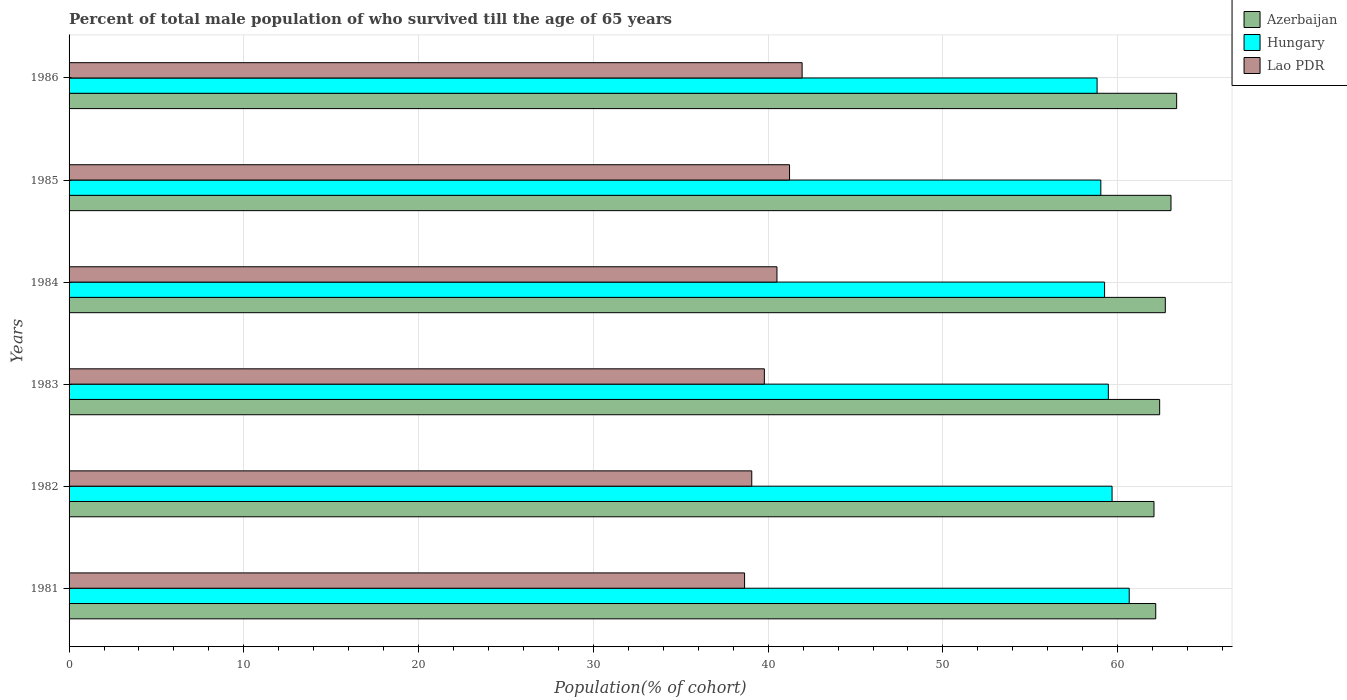How many different coloured bars are there?
Offer a very short reply. 3. How many groups of bars are there?
Make the answer very short. 6. What is the percentage of total male population who survived till the age of 65 years in Azerbaijan in 1984?
Ensure brevity in your answer.  62.73. Across all years, what is the maximum percentage of total male population who survived till the age of 65 years in Hungary?
Keep it short and to the point. 60.66. Across all years, what is the minimum percentage of total male population who survived till the age of 65 years in Hungary?
Give a very brief answer. 58.82. In which year was the percentage of total male population who survived till the age of 65 years in Lao PDR minimum?
Ensure brevity in your answer.  1981. What is the total percentage of total male population who survived till the age of 65 years in Azerbaijan in the graph?
Give a very brief answer. 375.81. What is the difference between the percentage of total male population who survived till the age of 65 years in Hungary in 1981 and that in 1984?
Keep it short and to the point. 1.41. What is the difference between the percentage of total male population who survived till the age of 65 years in Hungary in 1981 and the percentage of total male population who survived till the age of 65 years in Lao PDR in 1985?
Your answer should be compact. 19.44. What is the average percentage of total male population who survived till the age of 65 years in Lao PDR per year?
Provide a succinct answer. 40.19. In the year 1984, what is the difference between the percentage of total male population who survived till the age of 65 years in Azerbaijan and percentage of total male population who survived till the age of 65 years in Hungary?
Give a very brief answer. 3.48. What is the ratio of the percentage of total male population who survived till the age of 65 years in Hungary in 1983 to that in 1986?
Provide a short and direct response. 1.01. Is the difference between the percentage of total male population who survived till the age of 65 years in Azerbaijan in 1981 and 1983 greater than the difference between the percentage of total male population who survived till the age of 65 years in Hungary in 1981 and 1983?
Make the answer very short. No. What is the difference between the highest and the second highest percentage of total male population who survived till the age of 65 years in Lao PDR?
Ensure brevity in your answer.  0.72. What is the difference between the highest and the lowest percentage of total male population who survived till the age of 65 years in Lao PDR?
Offer a very short reply. 3.29. In how many years, is the percentage of total male population who survived till the age of 65 years in Hungary greater than the average percentage of total male population who survived till the age of 65 years in Hungary taken over all years?
Make the answer very short. 2. What does the 2nd bar from the top in 1984 represents?
Your answer should be very brief. Hungary. What does the 1st bar from the bottom in 1985 represents?
Provide a succinct answer. Azerbaijan. Is it the case that in every year, the sum of the percentage of total male population who survived till the age of 65 years in Lao PDR and percentage of total male population who survived till the age of 65 years in Hungary is greater than the percentage of total male population who survived till the age of 65 years in Azerbaijan?
Keep it short and to the point. Yes. Are the values on the major ticks of X-axis written in scientific E-notation?
Offer a very short reply. No. How many legend labels are there?
Ensure brevity in your answer.  3. What is the title of the graph?
Your answer should be very brief. Percent of total male population of who survived till the age of 65 years. Does "Cabo Verde" appear as one of the legend labels in the graph?
Your answer should be very brief. No. What is the label or title of the X-axis?
Make the answer very short. Population(% of cohort). What is the label or title of the Y-axis?
Your answer should be very brief. Years. What is the Population(% of cohort) of Azerbaijan in 1981?
Offer a very short reply. 62.18. What is the Population(% of cohort) in Hungary in 1981?
Make the answer very short. 60.66. What is the Population(% of cohort) of Lao PDR in 1981?
Offer a terse response. 38.65. What is the Population(% of cohort) in Azerbaijan in 1982?
Provide a succinct answer. 62.08. What is the Population(% of cohort) in Hungary in 1982?
Make the answer very short. 59.68. What is the Population(% of cohort) in Lao PDR in 1982?
Ensure brevity in your answer.  39.06. What is the Population(% of cohort) of Azerbaijan in 1983?
Your answer should be very brief. 62.4. What is the Population(% of cohort) of Hungary in 1983?
Your response must be concise. 59.46. What is the Population(% of cohort) in Lao PDR in 1983?
Give a very brief answer. 39.78. What is the Population(% of cohort) of Azerbaijan in 1984?
Your answer should be very brief. 62.73. What is the Population(% of cohort) of Hungary in 1984?
Ensure brevity in your answer.  59.25. What is the Population(% of cohort) of Lao PDR in 1984?
Your answer should be very brief. 40.5. What is the Population(% of cohort) of Azerbaijan in 1985?
Your answer should be very brief. 63.05. What is the Population(% of cohort) in Hungary in 1985?
Keep it short and to the point. 59.04. What is the Population(% of cohort) of Lao PDR in 1985?
Ensure brevity in your answer.  41.22. What is the Population(% of cohort) of Azerbaijan in 1986?
Ensure brevity in your answer.  63.37. What is the Population(% of cohort) in Hungary in 1986?
Your answer should be very brief. 58.82. What is the Population(% of cohort) in Lao PDR in 1986?
Ensure brevity in your answer.  41.94. Across all years, what is the maximum Population(% of cohort) in Azerbaijan?
Your response must be concise. 63.37. Across all years, what is the maximum Population(% of cohort) of Hungary?
Provide a short and direct response. 60.66. Across all years, what is the maximum Population(% of cohort) of Lao PDR?
Your answer should be very brief. 41.94. Across all years, what is the minimum Population(% of cohort) in Azerbaijan?
Offer a terse response. 62.08. Across all years, what is the minimum Population(% of cohort) in Hungary?
Provide a short and direct response. 58.82. Across all years, what is the minimum Population(% of cohort) in Lao PDR?
Your response must be concise. 38.65. What is the total Population(% of cohort) in Azerbaijan in the graph?
Your response must be concise. 375.81. What is the total Population(% of cohort) in Hungary in the graph?
Offer a very short reply. 356.91. What is the total Population(% of cohort) in Lao PDR in the graph?
Give a very brief answer. 241.17. What is the difference between the Population(% of cohort) in Azerbaijan in 1981 and that in 1982?
Ensure brevity in your answer.  0.1. What is the difference between the Population(% of cohort) in Hungary in 1981 and that in 1982?
Make the answer very short. 0.98. What is the difference between the Population(% of cohort) of Lao PDR in 1981 and that in 1982?
Offer a terse response. -0.41. What is the difference between the Population(% of cohort) of Azerbaijan in 1981 and that in 1983?
Provide a short and direct response. -0.22. What is the difference between the Population(% of cohort) of Hungary in 1981 and that in 1983?
Provide a succinct answer. 1.2. What is the difference between the Population(% of cohort) of Lao PDR in 1981 and that in 1983?
Offer a very short reply. -1.13. What is the difference between the Population(% of cohort) in Azerbaijan in 1981 and that in 1984?
Your answer should be compact. -0.55. What is the difference between the Population(% of cohort) in Hungary in 1981 and that in 1984?
Your answer should be compact. 1.41. What is the difference between the Population(% of cohort) of Lao PDR in 1981 and that in 1984?
Your answer should be compact. -1.85. What is the difference between the Population(% of cohort) of Azerbaijan in 1981 and that in 1985?
Your answer should be compact. -0.87. What is the difference between the Population(% of cohort) of Hungary in 1981 and that in 1985?
Your response must be concise. 1.62. What is the difference between the Population(% of cohort) of Lao PDR in 1981 and that in 1985?
Your response must be concise. -2.57. What is the difference between the Population(% of cohort) of Azerbaijan in 1981 and that in 1986?
Offer a very short reply. -1.2. What is the difference between the Population(% of cohort) in Hungary in 1981 and that in 1986?
Offer a very short reply. 1.84. What is the difference between the Population(% of cohort) of Lao PDR in 1981 and that in 1986?
Make the answer very short. -3.29. What is the difference between the Population(% of cohort) in Azerbaijan in 1982 and that in 1983?
Provide a succinct answer. -0.32. What is the difference between the Population(% of cohort) of Hungary in 1982 and that in 1983?
Offer a terse response. 0.21. What is the difference between the Population(% of cohort) of Lao PDR in 1982 and that in 1983?
Keep it short and to the point. -0.72. What is the difference between the Population(% of cohort) of Azerbaijan in 1982 and that in 1984?
Provide a short and direct response. -0.65. What is the difference between the Population(% of cohort) of Hungary in 1982 and that in 1984?
Offer a very short reply. 0.43. What is the difference between the Population(% of cohort) in Lao PDR in 1982 and that in 1984?
Offer a terse response. -1.44. What is the difference between the Population(% of cohort) of Azerbaijan in 1982 and that in 1985?
Give a very brief answer. -0.97. What is the difference between the Population(% of cohort) of Hungary in 1982 and that in 1985?
Keep it short and to the point. 0.64. What is the difference between the Population(% of cohort) of Lao PDR in 1982 and that in 1985?
Provide a short and direct response. -2.16. What is the difference between the Population(% of cohort) of Azerbaijan in 1982 and that in 1986?
Your answer should be compact. -1.3. What is the difference between the Population(% of cohort) in Hungary in 1982 and that in 1986?
Your answer should be very brief. 0.86. What is the difference between the Population(% of cohort) of Lao PDR in 1982 and that in 1986?
Ensure brevity in your answer.  -2.88. What is the difference between the Population(% of cohort) of Azerbaijan in 1983 and that in 1984?
Ensure brevity in your answer.  -0.32. What is the difference between the Population(% of cohort) in Hungary in 1983 and that in 1984?
Offer a very short reply. 0.21. What is the difference between the Population(% of cohort) of Lao PDR in 1983 and that in 1984?
Provide a succinct answer. -0.72. What is the difference between the Population(% of cohort) in Azerbaijan in 1983 and that in 1985?
Give a very brief answer. -0.65. What is the difference between the Population(% of cohort) of Hungary in 1983 and that in 1985?
Offer a very short reply. 0.43. What is the difference between the Population(% of cohort) in Lao PDR in 1983 and that in 1985?
Your answer should be compact. -1.44. What is the difference between the Population(% of cohort) of Azerbaijan in 1983 and that in 1986?
Your response must be concise. -0.97. What is the difference between the Population(% of cohort) in Hungary in 1983 and that in 1986?
Make the answer very short. 0.64. What is the difference between the Population(% of cohort) of Lao PDR in 1983 and that in 1986?
Your answer should be very brief. -2.16. What is the difference between the Population(% of cohort) of Azerbaijan in 1984 and that in 1985?
Ensure brevity in your answer.  -0.32. What is the difference between the Population(% of cohort) in Hungary in 1984 and that in 1985?
Ensure brevity in your answer.  0.21. What is the difference between the Population(% of cohort) in Lao PDR in 1984 and that in 1985?
Ensure brevity in your answer.  -0.72. What is the difference between the Population(% of cohort) of Azerbaijan in 1984 and that in 1986?
Keep it short and to the point. -0.65. What is the difference between the Population(% of cohort) in Hungary in 1984 and that in 1986?
Ensure brevity in your answer.  0.43. What is the difference between the Population(% of cohort) of Lao PDR in 1984 and that in 1986?
Offer a very short reply. -1.44. What is the difference between the Population(% of cohort) of Azerbaijan in 1985 and that in 1986?
Keep it short and to the point. -0.32. What is the difference between the Population(% of cohort) of Hungary in 1985 and that in 1986?
Your response must be concise. 0.21. What is the difference between the Population(% of cohort) of Lao PDR in 1985 and that in 1986?
Your answer should be very brief. -0.72. What is the difference between the Population(% of cohort) of Azerbaijan in 1981 and the Population(% of cohort) of Hungary in 1982?
Ensure brevity in your answer.  2.5. What is the difference between the Population(% of cohort) in Azerbaijan in 1981 and the Population(% of cohort) in Lao PDR in 1982?
Give a very brief answer. 23.11. What is the difference between the Population(% of cohort) of Hungary in 1981 and the Population(% of cohort) of Lao PDR in 1982?
Give a very brief answer. 21.6. What is the difference between the Population(% of cohort) of Azerbaijan in 1981 and the Population(% of cohort) of Hungary in 1983?
Give a very brief answer. 2.71. What is the difference between the Population(% of cohort) in Azerbaijan in 1981 and the Population(% of cohort) in Lao PDR in 1983?
Your answer should be compact. 22.39. What is the difference between the Population(% of cohort) of Hungary in 1981 and the Population(% of cohort) of Lao PDR in 1983?
Your response must be concise. 20.88. What is the difference between the Population(% of cohort) in Azerbaijan in 1981 and the Population(% of cohort) in Hungary in 1984?
Provide a succinct answer. 2.93. What is the difference between the Population(% of cohort) in Azerbaijan in 1981 and the Population(% of cohort) in Lao PDR in 1984?
Your answer should be compact. 21.67. What is the difference between the Population(% of cohort) of Hungary in 1981 and the Population(% of cohort) of Lao PDR in 1984?
Your answer should be compact. 20.16. What is the difference between the Population(% of cohort) of Azerbaijan in 1981 and the Population(% of cohort) of Hungary in 1985?
Keep it short and to the point. 3.14. What is the difference between the Population(% of cohort) in Azerbaijan in 1981 and the Population(% of cohort) in Lao PDR in 1985?
Provide a succinct answer. 20.95. What is the difference between the Population(% of cohort) of Hungary in 1981 and the Population(% of cohort) of Lao PDR in 1985?
Ensure brevity in your answer.  19.44. What is the difference between the Population(% of cohort) of Azerbaijan in 1981 and the Population(% of cohort) of Hungary in 1986?
Keep it short and to the point. 3.36. What is the difference between the Population(% of cohort) in Azerbaijan in 1981 and the Population(% of cohort) in Lao PDR in 1986?
Give a very brief answer. 20.23. What is the difference between the Population(% of cohort) in Hungary in 1981 and the Population(% of cohort) in Lao PDR in 1986?
Offer a terse response. 18.72. What is the difference between the Population(% of cohort) of Azerbaijan in 1982 and the Population(% of cohort) of Hungary in 1983?
Keep it short and to the point. 2.61. What is the difference between the Population(% of cohort) of Azerbaijan in 1982 and the Population(% of cohort) of Lao PDR in 1983?
Your answer should be compact. 22.29. What is the difference between the Population(% of cohort) in Hungary in 1982 and the Population(% of cohort) in Lao PDR in 1983?
Keep it short and to the point. 19.9. What is the difference between the Population(% of cohort) in Azerbaijan in 1982 and the Population(% of cohort) in Hungary in 1984?
Ensure brevity in your answer.  2.83. What is the difference between the Population(% of cohort) of Azerbaijan in 1982 and the Population(% of cohort) of Lao PDR in 1984?
Provide a succinct answer. 21.57. What is the difference between the Population(% of cohort) in Hungary in 1982 and the Population(% of cohort) in Lao PDR in 1984?
Offer a terse response. 19.18. What is the difference between the Population(% of cohort) of Azerbaijan in 1982 and the Population(% of cohort) of Hungary in 1985?
Ensure brevity in your answer.  3.04. What is the difference between the Population(% of cohort) of Azerbaijan in 1982 and the Population(% of cohort) of Lao PDR in 1985?
Your response must be concise. 20.85. What is the difference between the Population(% of cohort) in Hungary in 1982 and the Population(% of cohort) in Lao PDR in 1985?
Ensure brevity in your answer.  18.45. What is the difference between the Population(% of cohort) in Azerbaijan in 1982 and the Population(% of cohort) in Hungary in 1986?
Give a very brief answer. 3.26. What is the difference between the Population(% of cohort) of Azerbaijan in 1982 and the Population(% of cohort) of Lao PDR in 1986?
Your answer should be compact. 20.13. What is the difference between the Population(% of cohort) of Hungary in 1982 and the Population(% of cohort) of Lao PDR in 1986?
Provide a succinct answer. 17.73. What is the difference between the Population(% of cohort) in Azerbaijan in 1983 and the Population(% of cohort) in Hungary in 1984?
Your answer should be compact. 3.15. What is the difference between the Population(% of cohort) in Azerbaijan in 1983 and the Population(% of cohort) in Lao PDR in 1984?
Give a very brief answer. 21.9. What is the difference between the Population(% of cohort) of Hungary in 1983 and the Population(% of cohort) of Lao PDR in 1984?
Provide a short and direct response. 18.96. What is the difference between the Population(% of cohort) of Azerbaijan in 1983 and the Population(% of cohort) of Hungary in 1985?
Ensure brevity in your answer.  3.37. What is the difference between the Population(% of cohort) of Azerbaijan in 1983 and the Population(% of cohort) of Lao PDR in 1985?
Your response must be concise. 21.18. What is the difference between the Population(% of cohort) in Hungary in 1983 and the Population(% of cohort) in Lao PDR in 1985?
Your response must be concise. 18.24. What is the difference between the Population(% of cohort) in Azerbaijan in 1983 and the Population(% of cohort) in Hungary in 1986?
Your answer should be compact. 3.58. What is the difference between the Population(% of cohort) in Azerbaijan in 1983 and the Population(% of cohort) in Lao PDR in 1986?
Give a very brief answer. 20.46. What is the difference between the Population(% of cohort) in Hungary in 1983 and the Population(% of cohort) in Lao PDR in 1986?
Make the answer very short. 17.52. What is the difference between the Population(% of cohort) of Azerbaijan in 1984 and the Population(% of cohort) of Hungary in 1985?
Offer a very short reply. 3.69. What is the difference between the Population(% of cohort) in Azerbaijan in 1984 and the Population(% of cohort) in Lao PDR in 1985?
Ensure brevity in your answer.  21.5. What is the difference between the Population(% of cohort) in Hungary in 1984 and the Population(% of cohort) in Lao PDR in 1985?
Offer a very short reply. 18.03. What is the difference between the Population(% of cohort) of Azerbaijan in 1984 and the Population(% of cohort) of Hungary in 1986?
Make the answer very short. 3.9. What is the difference between the Population(% of cohort) in Azerbaijan in 1984 and the Population(% of cohort) in Lao PDR in 1986?
Ensure brevity in your answer.  20.78. What is the difference between the Population(% of cohort) in Hungary in 1984 and the Population(% of cohort) in Lao PDR in 1986?
Ensure brevity in your answer.  17.31. What is the difference between the Population(% of cohort) in Azerbaijan in 1985 and the Population(% of cohort) in Hungary in 1986?
Make the answer very short. 4.23. What is the difference between the Population(% of cohort) of Azerbaijan in 1985 and the Population(% of cohort) of Lao PDR in 1986?
Keep it short and to the point. 21.11. What is the difference between the Population(% of cohort) of Hungary in 1985 and the Population(% of cohort) of Lao PDR in 1986?
Offer a very short reply. 17.09. What is the average Population(% of cohort) in Azerbaijan per year?
Your answer should be very brief. 62.63. What is the average Population(% of cohort) of Hungary per year?
Ensure brevity in your answer.  59.49. What is the average Population(% of cohort) in Lao PDR per year?
Your response must be concise. 40.2. In the year 1981, what is the difference between the Population(% of cohort) in Azerbaijan and Population(% of cohort) in Hungary?
Make the answer very short. 1.52. In the year 1981, what is the difference between the Population(% of cohort) of Azerbaijan and Population(% of cohort) of Lao PDR?
Your answer should be very brief. 23.53. In the year 1981, what is the difference between the Population(% of cohort) in Hungary and Population(% of cohort) in Lao PDR?
Your answer should be compact. 22.01. In the year 1982, what is the difference between the Population(% of cohort) in Azerbaijan and Population(% of cohort) in Hungary?
Your response must be concise. 2.4. In the year 1982, what is the difference between the Population(% of cohort) in Azerbaijan and Population(% of cohort) in Lao PDR?
Your response must be concise. 23.01. In the year 1982, what is the difference between the Population(% of cohort) in Hungary and Population(% of cohort) in Lao PDR?
Keep it short and to the point. 20.62. In the year 1983, what is the difference between the Population(% of cohort) of Azerbaijan and Population(% of cohort) of Hungary?
Make the answer very short. 2.94. In the year 1983, what is the difference between the Population(% of cohort) of Azerbaijan and Population(% of cohort) of Lao PDR?
Your answer should be compact. 22.62. In the year 1983, what is the difference between the Population(% of cohort) of Hungary and Population(% of cohort) of Lao PDR?
Offer a very short reply. 19.68. In the year 1984, what is the difference between the Population(% of cohort) in Azerbaijan and Population(% of cohort) in Hungary?
Your response must be concise. 3.48. In the year 1984, what is the difference between the Population(% of cohort) of Azerbaijan and Population(% of cohort) of Lao PDR?
Give a very brief answer. 22.22. In the year 1984, what is the difference between the Population(% of cohort) of Hungary and Population(% of cohort) of Lao PDR?
Provide a succinct answer. 18.75. In the year 1985, what is the difference between the Population(% of cohort) in Azerbaijan and Population(% of cohort) in Hungary?
Offer a terse response. 4.01. In the year 1985, what is the difference between the Population(% of cohort) in Azerbaijan and Population(% of cohort) in Lao PDR?
Make the answer very short. 21.83. In the year 1985, what is the difference between the Population(% of cohort) in Hungary and Population(% of cohort) in Lao PDR?
Give a very brief answer. 17.81. In the year 1986, what is the difference between the Population(% of cohort) in Azerbaijan and Population(% of cohort) in Hungary?
Offer a very short reply. 4.55. In the year 1986, what is the difference between the Population(% of cohort) in Azerbaijan and Population(% of cohort) in Lao PDR?
Make the answer very short. 21.43. In the year 1986, what is the difference between the Population(% of cohort) in Hungary and Population(% of cohort) in Lao PDR?
Provide a short and direct response. 16.88. What is the ratio of the Population(% of cohort) of Hungary in 1981 to that in 1982?
Your answer should be very brief. 1.02. What is the ratio of the Population(% of cohort) of Lao PDR in 1981 to that in 1982?
Make the answer very short. 0.99. What is the ratio of the Population(% of cohort) in Hungary in 1981 to that in 1983?
Keep it short and to the point. 1.02. What is the ratio of the Population(% of cohort) in Lao PDR in 1981 to that in 1983?
Your answer should be compact. 0.97. What is the ratio of the Population(% of cohort) of Hungary in 1981 to that in 1984?
Keep it short and to the point. 1.02. What is the ratio of the Population(% of cohort) in Lao PDR in 1981 to that in 1984?
Make the answer very short. 0.95. What is the ratio of the Population(% of cohort) of Azerbaijan in 1981 to that in 1985?
Your response must be concise. 0.99. What is the ratio of the Population(% of cohort) of Hungary in 1981 to that in 1985?
Provide a short and direct response. 1.03. What is the ratio of the Population(% of cohort) in Lao PDR in 1981 to that in 1985?
Give a very brief answer. 0.94. What is the ratio of the Population(% of cohort) of Azerbaijan in 1981 to that in 1986?
Provide a short and direct response. 0.98. What is the ratio of the Population(% of cohort) of Hungary in 1981 to that in 1986?
Offer a terse response. 1.03. What is the ratio of the Population(% of cohort) in Lao PDR in 1981 to that in 1986?
Your answer should be very brief. 0.92. What is the ratio of the Population(% of cohort) in Hungary in 1982 to that in 1983?
Your answer should be compact. 1. What is the ratio of the Population(% of cohort) in Lao PDR in 1982 to that in 1983?
Provide a short and direct response. 0.98. What is the ratio of the Population(% of cohort) in Azerbaijan in 1982 to that in 1984?
Ensure brevity in your answer.  0.99. What is the ratio of the Population(% of cohort) in Hungary in 1982 to that in 1984?
Provide a short and direct response. 1.01. What is the ratio of the Population(% of cohort) of Lao PDR in 1982 to that in 1984?
Ensure brevity in your answer.  0.96. What is the ratio of the Population(% of cohort) of Azerbaijan in 1982 to that in 1985?
Make the answer very short. 0.98. What is the ratio of the Population(% of cohort) in Hungary in 1982 to that in 1985?
Offer a terse response. 1.01. What is the ratio of the Population(% of cohort) in Lao PDR in 1982 to that in 1985?
Provide a short and direct response. 0.95. What is the ratio of the Population(% of cohort) of Azerbaijan in 1982 to that in 1986?
Your response must be concise. 0.98. What is the ratio of the Population(% of cohort) in Hungary in 1982 to that in 1986?
Make the answer very short. 1.01. What is the ratio of the Population(% of cohort) in Lao PDR in 1982 to that in 1986?
Provide a succinct answer. 0.93. What is the ratio of the Population(% of cohort) in Lao PDR in 1983 to that in 1984?
Offer a very short reply. 0.98. What is the ratio of the Population(% of cohort) of Azerbaijan in 1983 to that in 1985?
Offer a very short reply. 0.99. What is the ratio of the Population(% of cohort) in Hungary in 1983 to that in 1985?
Your response must be concise. 1.01. What is the ratio of the Population(% of cohort) in Lao PDR in 1983 to that in 1985?
Provide a short and direct response. 0.96. What is the ratio of the Population(% of cohort) of Azerbaijan in 1983 to that in 1986?
Provide a short and direct response. 0.98. What is the ratio of the Population(% of cohort) in Hungary in 1983 to that in 1986?
Your response must be concise. 1.01. What is the ratio of the Population(% of cohort) of Lao PDR in 1983 to that in 1986?
Your answer should be compact. 0.95. What is the ratio of the Population(% of cohort) in Hungary in 1984 to that in 1985?
Offer a terse response. 1. What is the ratio of the Population(% of cohort) of Lao PDR in 1984 to that in 1985?
Your answer should be very brief. 0.98. What is the ratio of the Population(% of cohort) of Azerbaijan in 1984 to that in 1986?
Your answer should be very brief. 0.99. What is the ratio of the Population(% of cohort) in Hungary in 1984 to that in 1986?
Give a very brief answer. 1.01. What is the ratio of the Population(% of cohort) in Lao PDR in 1984 to that in 1986?
Ensure brevity in your answer.  0.97. What is the ratio of the Population(% of cohort) of Lao PDR in 1985 to that in 1986?
Keep it short and to the point. 0.98. What is the difference between the highest and the second highest Population(% of cohort) in Azerbaijan?
Ensure brevity in your answer.  0.32. What is the difference between the highest and the second highest Population(% of cohort) of Hungary?
Provide a succinct answer. 0.98. What is the difference between the highest and the second highest Population(% of cohort) of Lao PDR?
Your response must be concise. 0.72. What is the difference between the highest and the lowest Population(% of cohort) of Azerbaijan?
Provide a succinct answer. 1.3. What is the difference between the highest and the lowest Population(% of cohort) in Hungary?
Keep it short and to the point. 1.84. What is the difference between the highest and the lowest Population(% of cohort) in Lao PDR?
Your answer should be very brief. 3.29. 